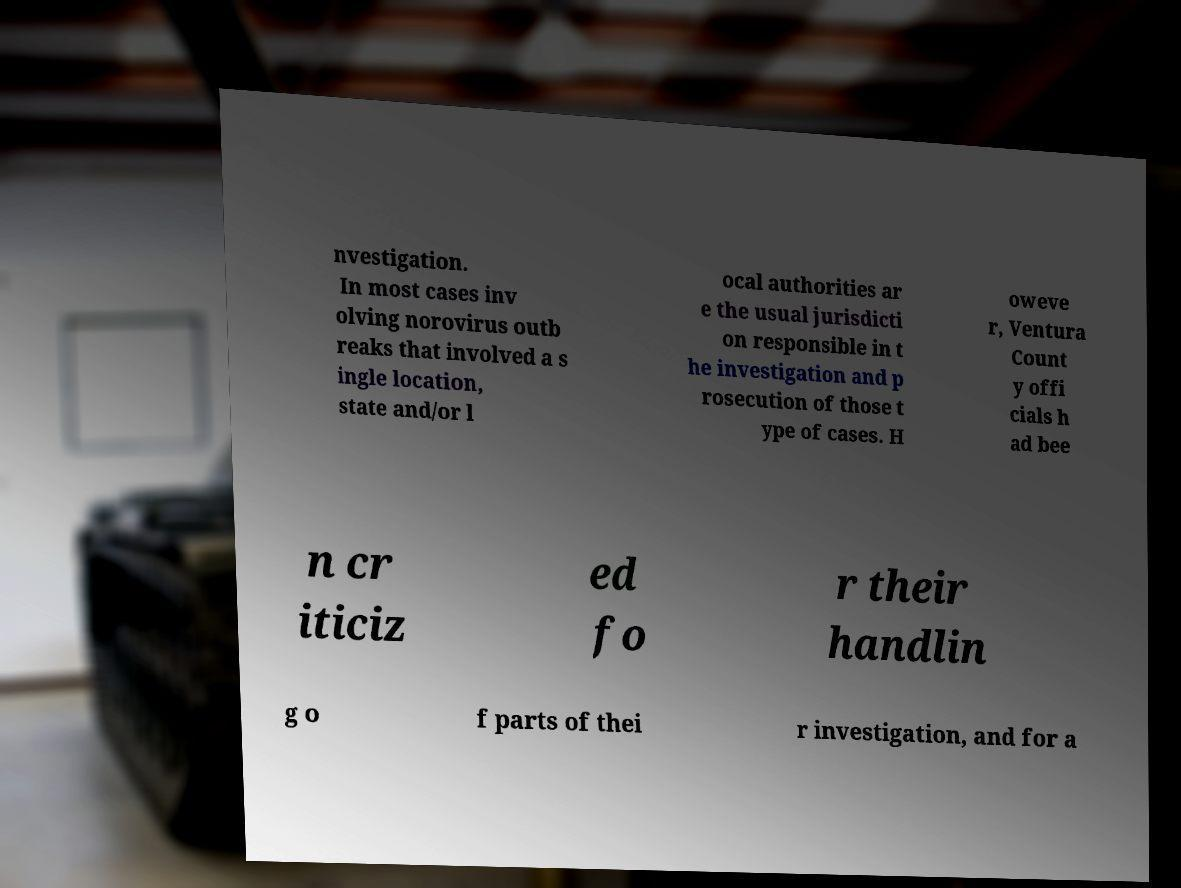Could you assist in decoding the text presented in this image and type it out clearly? nvestigation. In most cases inv olving norovirus outb reaks that involved a s ingle location, state and/or l ocal authorities ar e the usual jurisdicti on responsible in t he investigation and p rosecution of those t ype of cases. H oweve r, Ventura Count y offi cials h ad bee n cr iticiz ed fo r their handlin g o f parts of thei r investigation, and for a 